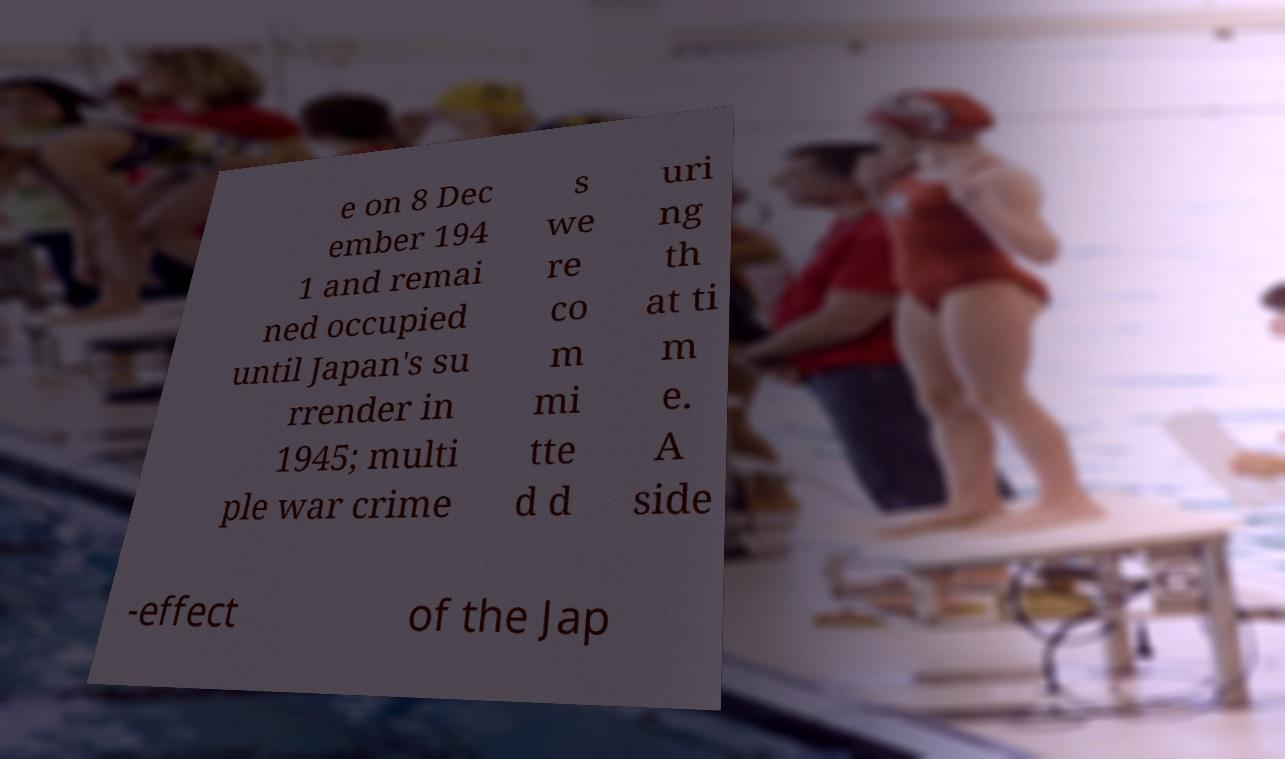What messages or text are displayed in this image? I need them in a readable, typed format. e on 8 Dec ember 194 1 and remai ned occupied until Japan's su rrender in 1945; multi ple war crime s we re co m mi tte d d uri ng th at ti m e. A side -effect of the Jap 